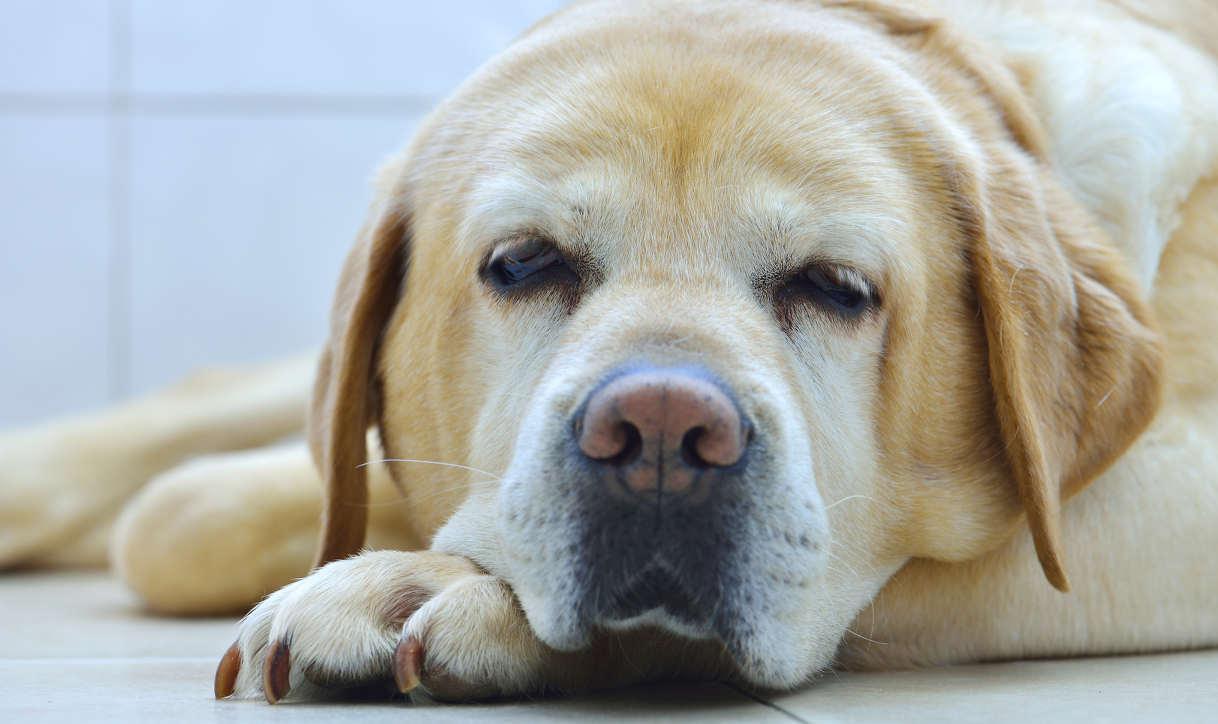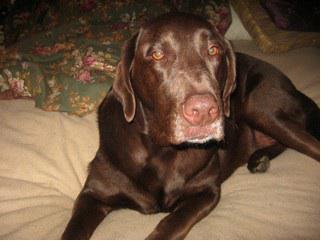The first image is the image on the left, the second image is the image on the right. Analyze the images presented: Is the assertion "One image contains exactly one reclining chocolate-brown dog." valid? Answer yes or no. Yes. The first image is the image on the left, the second image is the image on the right. Considering the images on both sides, is "There is one black dog that has its mouth open in one of the images." valid? Answer yes or no. No. 